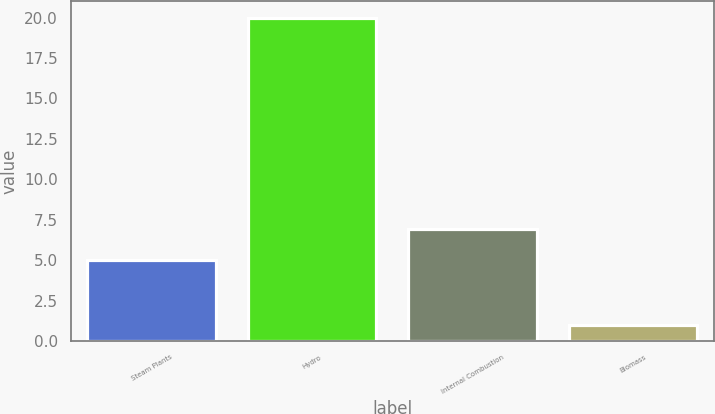Convert chart. <chart><loc_0><loc_0><loc_500><loc_500><bar_chart><fcel>Steam Plants<fcel>Hydro<fcel>Internal Combustion<fcel>Biomass<nl><fcel>5<fcel>20<fcel>6.9<fcel>1<nl></chart> 